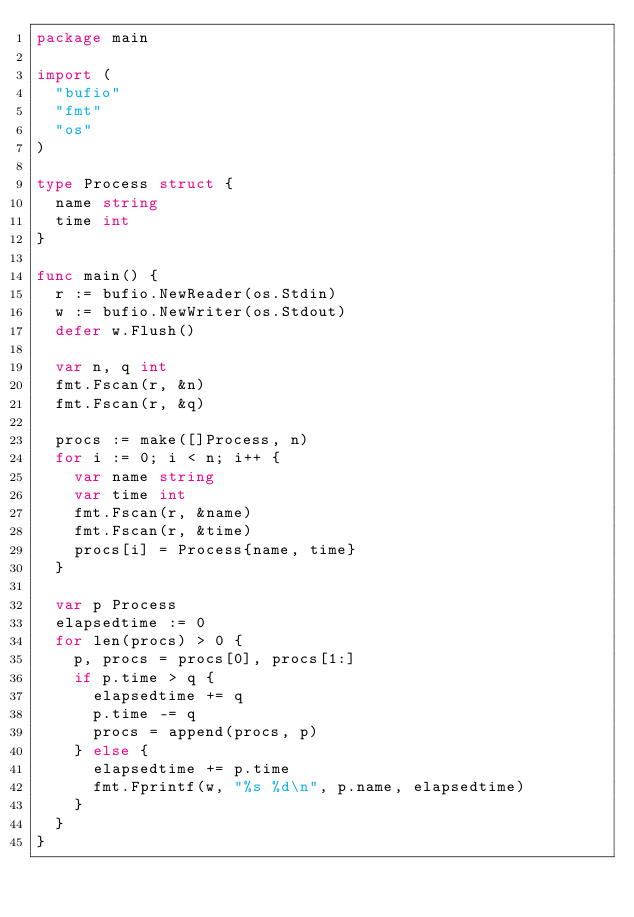<code> <loc_0><loc_0><loc_500><loc_500><_Go_>package main

import (
	"bufio"
	"fmt"
	"os"
)

type Process struct {
	name string
	time int
}

func main() {
	r := bufio.NewReader(os.Stdin)
	w := bufio.NewWriter(os.Stdout)
	defer w.Flush()

	var n, q int
	fmt.Fscan(r, &n)
	fmt.Fscan(r, &q)

	procs := make([]Process, n)
	for i := 0; i < n; i++ {
		var name string
		var time int
		fmt.Fscan(r, &name)
		fmt.Fscan(r, &time)
		procs[i] = Process{name, time}
	}

	var p Process
	elapsedtime := 0
	for len(procs) > 0 {
		p, procs = procs[0], procs[1:]
		if p.time > q {
			elapsedtime += q
			p.time -= q
			procs = append(procs, p)
		} else {
			elapsedtime += p.time
			fmt.Fprintf(w, "%s %d\n", p.name, elapsedtime)
		}
	}
}

</code> 